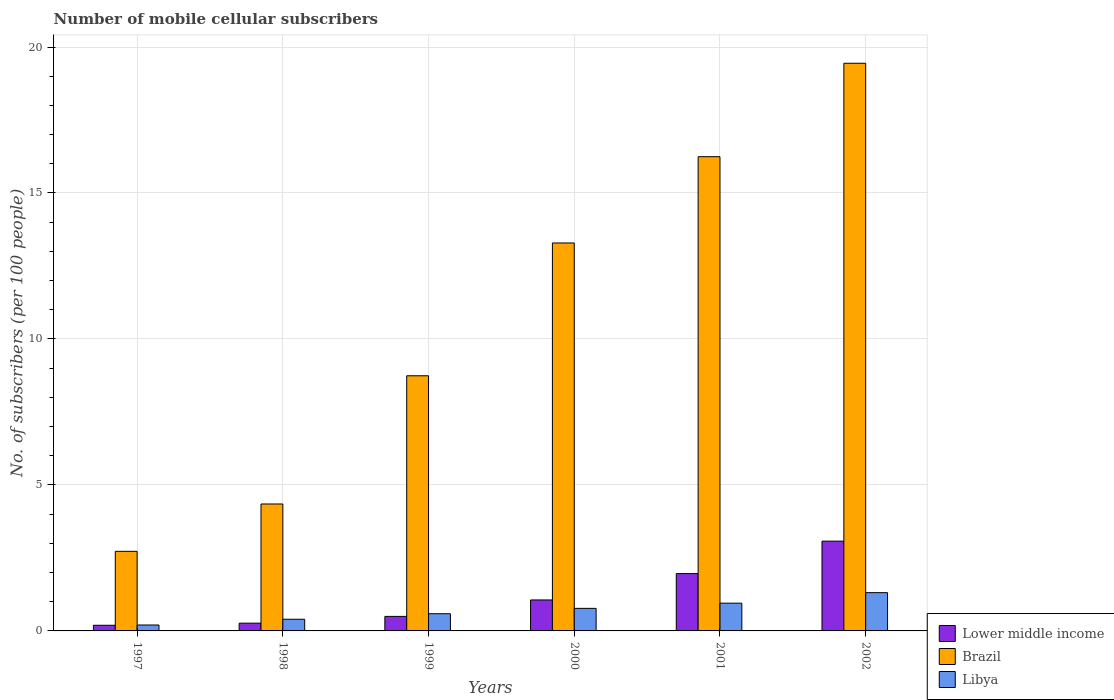How many different coloured bars are there?
Give a very brief answer. 3. How many groups of bars are there?
Offer a terse response. 6. Are the number of bars per tick equal to the number of legend labels?
Offer a terse response. Yes. How many bars are there on the 6th tick from the left?
Your response must be concise. 3. What is the label of the 1st group of bars from the left?
Your response must be concise. 1997. What is the number of mobile cellular subscribers in Brazil in 1999?
Offer a terse response. 8.74. Across all years, what is the maximum number of mobile cellular subscribers in Brazil?
Provide a succinct answer. 19.44. Across all years, what is the minimum number of mobile cellular subscribers in Libya?
Your response must be concise. 0.2. In which year was the number of mobile cellular subscribers in Libya maximum?
Your response must be concise. 2002. In which year was the number of mobile cellular subscribers in Brazil minimum?
Your answer should be very brief. 1997. What is the total number of mobile cellular subscribers in Libya in the graph?
Provide a succinct answer. 4.23. What is the difference between the number of mobile cellular subscribers in Libya in 2000 and that in 2001?
Keep it short and to the point. -0.18. What is the difference between the number of mobile cellular subscribers in Brazil in 2002 and the number of mobile cellular subscribers in Libya in 1999?
Provide a succinct answer. 18.85. What is the average number of mobile cellular subscribers in Libya per year?
Ensure brevity in your answer.  0.7. In the year 1998, what is the difference between the number of mobile cellular subscribers in Libya and number of mobile cellular subscribers in Lower middle income?
Give a very brief answer. 0.13. What is the ratio of the number of mobile cellular subscribers in Brazil in 1998 to that in 2000?
Offer a terse response. 0.33. Is the difference between the number of mobile cellular subscribers in Libya in 2000 and 2002 greater than the difference between the number of mobile cellular subscribers in Lower middle income in 2000 and 2002?
Provide a short and direct response. Yes. What is the difference between the highest and the second highest number of mobile cellular subscribers in Brazil?
Offer a very short reply. 3.2. What is the difference between the highest and the lowest number of mobile cellular subscribers in Brazil?
Your response must be concise. 16.72. In how many years, is the number of mobile cellular subscribers in Libya greater than the average number of mobile cellular subscribers in Libya taken over all years?
Provide a short and direct response. 3. Is the sum of the number of mobile cellular subscribers in Brazil in 1999 and 2001 greater than the maximum number of mobile cellular subscribers in Lower middle income across all years?
Make the answer very short. Yes. What does the 1st bar from the left in 1999 represents?
Your answer should be compact. Lower middle income. What does the 1st bar from the right in 1999 represents?
Provide a short and direct response. Libya. How many bars are there?
Provide a short and direct response. 18. Are all the bars in the graph horizontal?
Keep it short and to the point. No. How many years are there in the graph?
Keep it short and to the point. 6. Are the values on the major ticks of Y-axis written in scientific E-notation?
Ensure brevity in your answer.  No. Does the graph contain grids?
Offer a terse response. Yes. How many legend labels are there?
Keep it short and to the point. 3. How are the legend labels stacked?
Give a very brief answer. Vertical. What is the title of the graph?
Offer a terse response. Number of mobile cellular subscribers. What is the label or title of the X-axis?
Your answer should be compact. Years. What is the label or title of the Y-axis?
Offer a very short reply. No. of subscribers (per 100 people). What is the No. of subscribers (per 100 people) in Lower middle income in 1997?
Your response must be concise. 0.19. What is the No. of subscribers (per 100 people) in Brazil in 1997?
Ensure brevity in your answer.  2.73. What is the No. of subscribers (per 100 people) in Libya in 1997?
Provide a short and direct response. 0.2. What is the No. of subscribers (per 100 people) in Lower middle income in 1998?
Make the answer very short. 0.27. What is the No. of subscribers (per 100 people) of Brazil in 1998?
Provide a short and direct response. 4.35. What is the No. of subscribers (per 100 people) in Libya in 1998?
Make the answer very short. 0.4. What is the No. of subscribers (per 100 people) in Lower middle income in 1999?
Provide a short and direct response. 0.5. What is the No. of subscribers (per 100 people) in Brazil in 1999?
Provide a short and direct response. 8.74. What is the No. of subscribers (per 100 people) in Libya in 1999?
Your answer should be compact. 0.59. What is the No. of subscribers (per 100 people) in Lower middle income in 2000?
Offer a terse response. 1.06. What is the No. of subscribers (per 100 people) in Brazil in 2000?
Give a very brief answer. 13.29. What is the No. of subscribers (per 100 people) of Libya in 2000?
Provide a short and direct response. 0.77. What is the No. of subscribers (per 100 people) in Lower middle income in 2001?
Your response must be concise. 1.96. What is the No. of subscribers (per 100 people) in Brazil in 2001?
Give a very brief answer. 16.24. What is the No. of subscribers (per 100 people) of Libya in 2001?
Your response must be concise. 0.95. What is the No. of subscribers (per 100 people) of Lower middle income in 2002?
Your answer should be very brief. 3.07. What is the No. of subscribers (per 100 people) of Brazil in 2002?
Offer a terse response. 19.44. What is the No. of subscribers (per 100 people) in Libya in 2002?
Your answer should be very brief. 1.31. Across all years, what is the maximum No. of subscribers (per 100 people) in Lower middle income?
Offer a very short reply. 3.07. Across all years, what is the maximum No. of subscribers (per 100 people) in Brazil?
Your response must be concise. 19.44. Across all years, what is the maximum No. of subscribers (per 100 people) in Libya?
Offer a terse response. 1.31. Across all years, what is the minimum No. of subscribers (per 100 people) in Lower middle income?
Your answer should be compact. 0.19. Across all years, what is the minimum No. of subscribers (per 100 people) of Brazil?
Give a very brief answer. 2.73. Across all years, what is the minimum No. of subscribers (per 100 people) in Libya?
Provide a short and direct response. 0.2. What is the total No. of subscribers (per 100 people) in Lower middle income in the graph?
Offer a terse response. 7.06. What is the total No. of subscribers (per 100 people) of Brazil in the graph?
Give a very brief answer. 64.79. What is the total No. of subscribers (per 100 people) in Libya in the graph?
Give a very brief answer. 4.23. What is the difference between the No. of subscribers (per 100 people) in Lower middle income in 1997 and that in 1998?
Your answer should be compact. -0.07. What is the difference between the No. of subscribers (per 100 people) of Brazil in 1997 and that in 1998?
Your answer should be compact. -1.62. What is the difference between the No. of subscribers (per 100 people) of Libya in 1997 and that in 1998?
Ensure brevity in your answer.  -0.2. What is the difference between the No. of subscribers (per 100 people) in Lower middle income in 1997 and that in 1999?
Your answer should be compact. -0.3. What is the difference between the No. of subscribers (per 100 people) in Brazil in 1997 and that in 1999?
Ensure brevity in your answer.  -6.01. What is the difference between the No. of subscribers (per 100 people) of Libya in 1997 and that in 1999?
Give a very brief answer. -0.39. What is the difference between the No. of subscribers (per 100 people) of Lower middle income in 1997 and that in 2000?
Give a very brief answer. -0.87. What is the difference between the No. of subscribers (per 100 people) of Brazil in 1997 and that in 2000?
Give a very brief answer. -10.56. What is the difference between the No. of subscribers (per 100 people) in Libya in 1997 and that in 2000?
Your answer should be very brief. -0.57. What is the difference between the No. of subscribers (per 100 people) in Lower middle income in 1997 and that in 2001?
Your answer should be very brief. -1.77. What is the difference between the No. of subscribers (per 100 people) in Brazil in 1997 and that in 2001?
Offer a very short reply. -13.52. What is the difference between the No. of subscribers (per 100 people) in Libya in 1997 and that in 2001?
Provide a succinct answer. -0.75. What is the difference between the No. of subscribers (per 100 people) of Lower middle income in 1997 and that in 2002?
Keep it short and to the point. -2.88. What is the difference between the No. of subscribers (per 100 people) of Brazil in 1997 and that in 2002?
Offer a very short reply. -16.72. What is the difference between the No. of subscribers (per 100 people) in Libya in 1997 and that in 2002?
Provide a succinct answer. -1.11. What is the difference between the No. of subscribers (per 100 people) in Lower middle income in 1998 and that in 1999?
Your answer should be compact. -0.23. What is the difference between the No. of subscribers (per 100 people) of Brazil in 1998 and that in 1999?
Make the answer very short. -4.39. What is the difference between the No. of subscribers (per 100 people) of Libya in 1998 and that in 1999?
Your answer should be compact. -0.19. What is the difference between the No. of subscribers (per 100 people) of Lower middle income in 1998 and that in 2000?
Your response must be concise. -0.79. What is the difference between the No. of subscribers (per 100 people) of Brazil in 1998 and that in 2000?
Ensure brevity in your answer.  -8.94. What is the difference between the No. of subscribers (per 100 people) of Libya in 1998 and that in 2000?
Offer a very short reply. -0.37. What is the difference between the No. of subscribers (per 100 people) of Lower middle income in 1998 and that in 2001?
Your answer should be very brief. -1.7. What is the difference between the No. of subscribers (per 100 people) of Brazil in 1998 and that in 2001?
Ensure brevity in your answer.  -11.9. What is the difference between the No. of subscribers (per 100 people) of Libya in 1998 and that in 2001?
Your response must be concise. -0.55. What is the difference between the No. of subscribers (per 100 people) in Lower middle income in 1998 and that in 2002?
Ensure brevity in your answer.  -2.81. What is the difference between the No. of subscribers (per 100 people) in Brazil in 1998 and that in 2002?
Ensure brevity in your answer.  -15.1. What is the difference between the No. of subscribers (per 100 people) of Libya in 1998 and that in 2002?
Provide a succinct answer. -0.91. What is the difference between the No. of subscribers (per 100 people) in Lower middle income in 1999 and that in 2000?
Your answer should be very brief. -0.56. What is the difference between the No. of subscribers (per 100 people) of Brazil in 1999 and that in 2000?
Provide a short and direct response. -4.55. What is the difference between the No. of subscribers (per 100 people) of Libya in 1999 and that in 2000?
Ensure brevity in your answer.  -0.18. What is the difference between the No. of subscribers (per 100 people) of Lower middle income in 1999 and that in 2001?
Give a very brief answer. -1.47. What is the difference between the No. of subscribers (per 100 people) in Brazil in 1999 and that in 2001?
Your answer should be compact. -7.5. What is the difference between the No. of subscribers (per 100 people) in Libya in 1999 and that in 2001?
Your response must be concise. -0.36. What is the difference between the No. of subscribers (per 100 people) of Lower middle income in 1999 and that in 2002?
Give a very brief answer. -2.58. What is the difference between the No. of subscribers (per 100 people) in Brazil in 1999 and that in 2002?
Your response must be concise. -10.7. What is the difference between the No. of subscribers (per 100 people) of Libya in 1999 and that in 2002?
Give a very brief answer. -0.72. What is the difference between the No. of subscribers (per 100 people) in Lower middle income in 2000 and that in 2001?
Provide a short and direct response. -0.9. What is the difference between the No. of subscribers (per 100 people) in Brazil in 2000 and that in 2001?
Make the answer very short. -2.96. What is the difference between the No. of subscribers (per 100 people) of Libya in 2000 and that in 2001?
Make the answer very short. -0.18. What is the difference between the No. of subscribers (per 100 people) in Lower middle income in 2000 and that in 2002?
Your answer should be compact. -2.01. What is the difference between the No. of subscribers (per 100 people) of Brazil in 2000 and that in 2002?
Provide a succinct answer. -6.16. What is the difference between the No. of subscribers (per 100 people) of Libya in 2000 and that in 2002?
Make the answer very short. -0.54. What is the difference between the No. of subscribers (per 100 people) in Lower middle income in 2001 and that in 2002?
Give a very brief answer. -1.11. What is the difference between the No. of subscribers (per 100 people) of Brazil in 2001 and that in 2002?
Ensure brevity in your answer.  -3.2. What is the difference between the No. of subscribers (per 100 people) in Libya in 2001 and that in 2002?
Provide a succinct answer. -0.36. What is the difference between the No. of subscribers (per 100 people) of Lower middle income in 1997 and the No. of subscribers (per 100 people) of Brazil in 1998?
Your answer should be compact. -4.15. What is the difference between the No. of subscribers (per 100 people) in Lower middle income in 1997 and the No. of subscribers (per 100 people) in Libya in 1998?
Keep it short and to the point. -0.21. What is the difference between the No. of subscribers (per 100 people) of Brazil in 1997 and the No. of subscribers (per 100 people) of Libya in 1998?
Your answer should be very brief. 2.33. What is the difference between the No. of subscribers (per 100 people) of Lower middle income in 1997 and the No. of subscribers (per 100 people) of Brazil in 1999?
Ensure brevity in your answer.  -8.55. What is the difference between the No. of subscribers (per 100 people) in Lower middle income in 1997 and the No. of subscribers (per 100 people) in Libya in 1999?
Give a very brief answer. -0.4. What is the difference between the No. of subscribers (per 100 people) of Brazil in 1997 and the No. of subscribers (per 100 people) of Libya in 1999?
Make the answer very short. 2.14. What is the difference between the No. of subscribers (per 100 people) of Lower middle income in 1997 and the No. of subscribers (per 100 people) of Brazil in 2000?
Ensure brevity in your answer.  -13.09. What is the difference between the No. of subscribers (per 100 people) in Lower middle income in 1997 and the No. of subscribers (per 100 people) in Libya in 2000?
Provide a succinct answer. -0.58. What is the difference between the No. of subscribers (per 100 people) of Brazil in 1997 and the No. of subscribers (per 100 people) of Libya in 2000?
Give a very brief answer. 1.95. What is the difference between the No. of subscribers (per 100 people) in Lower middle income in 1997 and the No. of subscribers (per 100 people) in Brazil in 2001?
Offer a terse response. -16.05. What is the difference between the No. of subscribers (per 100 people) in Lower middle income in 1997 and the No. of subscribers (per 100 people) in Libya in 2001?
Give a very brief answer. -0.76. What is the difference between the No. of subscribers (per 100 people) in Brazil in 1997 and the No. of subscribers (per 100 people) in Libya in 2001?
Your answer should be very brief. 1.77. What is the difference between the No. of subscribers (per 100 people) in Lower middle income in 1997 and the No. of subscribers (per 100 people) in Brazil in 2002?
Provide a short and direct response. -19.25. What is the difference between the No. of subscribers (per 100 people) of Lower middle income in 1997 and the No. of subscribers (per 100 people) of Libya in 2002?
Provide a short and direct response. -1.12. What is the difference between the No. of subscribers (per 100 people) of Brazil in 1997 and the No. of subscribers (per 100 people) of Libya in 2002?
Your answer should be very brief. 1.42. What is the difference between the No. of subscribers (per 100 people) of Lower middle income in 1998 and the No. of subscribers (per 100 people) of Brazil in 1999?
Make the answer very short. -8.47. What is the difference between the No. of subscribers (per 100 people) in Lower middle income in 1998 and the No. of subscribers (per 100 people) in Libya in 1999?
Your answer should be very brief. -0.32. What is the difference between the No. of subscribers (per 100 people) in Brazil in 1998 and the No. of subscribers (per 100 people) in Libya in 1999?
Keep it short and to the point. 3.76. What is the difference between the No. of subscribers (per 100 people) of Lower middle income in 1998 and the No. of subscribers (per 100 people) of Brazil in 2000?
Your response must be concise. -13.02. What is the difference between the No. of subscribers (per 100 people) in Lower middle income in 1998 and the No. of subscribers (per 100 people) in Libya in 2000?
Your answer should be very brief. -0.51. What is the difference between the No. of subscribers (per 100 people) of Brazil in 1998 and the No. of subscribers (per 100 people) of Libya in 2000?
Your answer should be compact. 3.58. What is the difference between the No. of subscribers (per 100 people) in Lower middle income in 1998 and the No. of subscribers (per 100 people) in Brazil in 2001?
Offer a very short reply. -15.98. What is the difference between the No. of subscribers (per 100 people) of Lower middle income in 1998 and the No. of subscribers (per 100 people) of Libya in 2001?
Provide a short and direct response. -0.69. What is the difference between the No. of subscribers (per 100 people) of Brazil in 1998 and the No. of subscribers (per 100 people) of Libya in 2001?
Keep it short and to the point. 3.4. What is the difference between the No. of subscribers (per 100 people) in Lower middle income in 1998 and the No. of subscribers (per 100 people) in Brazil in 2002?
Your response must be concise. -19.18. What is the difference between the No. of subscribers (per 100 people) in Lower middle income in 1998 and the No. of subscribers (per 100 people) in Libya in 2002?
Your answer should be compact. -1.04. What is the difference between the No. of subscribers (per 100 people) in Brazil in 1998 and the No. of subscribers (per 100 people) in Libya in 2002?
Your answer should be very brief. 3.04. What is the difference between the No. of subscribers (per 100 people) in Lower middle income in 1999 and the No. of subscribers (per 100 people) in Brazil in 2000?
Your answer should be compact. -12.79. What is the difference between the No. of subscribers (per 100 people) in Lower middle income in 1999 and the No. of subscribers (per 100 people) in Libya in 2000?
Give a very brief answer. -0.28. What is the difference between the No. of subscribers (per 100 people) in Brazil in 1999 and the No. of subscribers (per 100 people) in Libya in 2000?
Keep it short and to the point. 7.97. What is the difference between the No. of subscribers (per 100 people) in Lower middle income in 1999 and the No. of subscribers (per 100 people) in Brazil in 2001?
Offer a very short reply. -15.75. What is the difference between the No. of subscribers (per 100 people) in Lower middle income in 1999 and the No. of subscribers (per 100 people) in Libya in 2001?
Keep it short and to the point. -0.45. What is the difference between the No. of subscribers (per 100 people) of Brazil in 1999 and the No. of subscribers (per 100 people) of Libya in 2001?
Offer a very short reply. 7.79. What is the difference between the No. of subscribers (per 100 people) in Lower middle income in 1999 and the No. of subscribers (per 100 people) in Brazil in 2002?
Your answer should be very brief. -18.95. What is the difference between the No. of subscribers (per 100 people) in Lower middle income in 1999 and the No. of subscribers (per 100 people) in Libya in 2002?
Offer a very short reply. -0.81. What is the difference between the No. of subscribers (per 100 people) in Brazil in 1999 and the No. of subscribers (per 100 people) in Libya in 2002?
Give a very brief answer. 7.43. What is the difference between the No. of subscribers (per 100 people) in Lower middle income in 2000 and the No. of subscribers (per 100 people) in Brazil in 2001?
Provide a succinct answer. -15.18. What is the difference between the No. of subscribers (per 100 people) of Lower middle income in 2000 and the No. of subscribers (per 100 people) of Libya in 2001?
Offer a terse response. 0.11. What is the difference between the No. of subscribers (per 100 people) in Brazil in 2000 and the No. of subscribers (per 100 people) in Libya in 2001?
Your answer should be compact. 12.34. What is the difference between the No. of subscribers (per 100 people) of Lower middle income in 2000 and the No. of subscribers (per 100 people) of Brazil in 2002?
Offer a terse response. -18.38. What is the difference between the No. of subscribers (per 100 people) of Brazil in 2000 and the No. of subscribers (per 100 people) of Libya in 2002?
Your response must be concise. 11.98. What is the difference between the No. of subscribers (per 100 people) in Lower middle income in 2001 and the No. of subscribers (per 100 people) in Brazil in 2002?
Provide a short and direct response. -17.48. What is the difference between the No. of subscribers (per 100 people) of Lower middle income in 2001 and the No. of subscribers (per 100 people) of Libya in 2002?
Offer a terse response. 0.65. What is the difference between the No. of subscribers (per 100 people) in Brazil in 2001 and the No. of subscribers (per 100 people) in Libya in 2002?
Keep it short and to the point. 14.93. What is the average No. of subscribers (per 100 people) of Lower middle income per year?
Offer a very short reply. 1.18. What is the average No. of subscribers (per 100 people) in Brazil per year?
Ensure brevity in your answer.  10.8. What is the average No. of subscribers (per 100 people) in Libya per year?
Give a very brief answer. 0.7. In the year 1997, what is the difference between the No. of subscribers (per 100 people) in Lower middle income and No. of subscribers (per 100 people) in Brazil?
Ensure brevity in your answer.  -2.53. In the year 1997, what is the difference between the No. of subscribers (per 100 people) in Lower middle income and No. of subscribers (per 100 people) in Libya?
Ensure brevity in your answer.  -0.01. In the year 1997, what is the difference between the No. of subscribers (per 100 people) of Brazil and No. of subscribers (per 100 people) of Libya?
Your response must be concise. 2.52. In the year 1998, what is the difference between the No. of subscribers (per 100 people) in Lower middle income and No. of subscribers (per 100 people) in Brazil?
Offer a very short reply. -4.08. In the year 1998, what is the difference between the No. of subscribers (per 100 people) in Lower middle income and No. of subscribers (per 100 people) in Libya?
Make the answer very short. -0.13. In the year 1998, what is the difference between the No. of subscribers (per 100 people) in Brazil and No. of subscribers (per 100 people) in Libya?
Give a very brief answer. 3.95. In the year 1999, what is the difference between the No. of subscribers (per 100 people) in Lower middle income and No. of subscribers (per 100 people) in Brazil?
Your answer should be compact. -8.24. In the year 1999, what is the difference between the No. of subscribers (per 100 people) of Lower middle income and No. of subscribers (per 100 people) of Libya?
Your answer should be very brief. -0.09. In the year 1999, what is the difference between the No. of subscribers (per 100 people) of Brazil and No. of subscribers (per 100 people) of Libya?
Give a very brief answer. 8.15. In the year 2000, what is the difference between the No. of subscribers (per 100 people) in Lower middle income and No. of subscribers (per 100 people) in Brazil?
Your response must be concise. -12.23. In the year 2000, what is the difference between the No. of subscribers (per 100 people) in Lower middle income and No. of subscribers (per 100 people) in Libya?
Make the answer very short. 0.29. In the year 2000, what is the difference between the No. of subscribers (per 100 people) in Brazil and No. of subscribers (per 100 people) in Libya?
Offer a terse response. 12.52. In the year 2001, what is the difference between the No. of subscribers (per 100 people) in Lower middle income and No. of subscribers (per 100 people) in Brazil?
Keep it short and to the point. -14.28. In the year 2001, what is the difference between the No. of subscribers (per 100 people) of Lower middle income and No. of subscribers (per 100 people) of Libya?
Make the answer very short. 1.01. In the year 2001, what is the difference between the No. of subscribers (per 100 people) in Brazil and No. of subscribers (per 100 people) in Libya?
Give a very brief answer. 15.29. In the year 2002, what is the difference between the No. of subscribers (per 100 people) of Lower middle income and No. of subscribers (per 100 people) of Brazil?
Keep it short and to the point. -16.37. In the year 2002, what is the difference between the No. of subscribers (per 100 people) of Lower middle income and No. of subscribers (per 100 people) of Libya?
Offer a very short reply. 1.76. In the year 2002, what is the difference between the No. of subscribers (per 100 people) of Brazil and No. of subscribers (per 100 people) of Libya?
Ensure brevity in your answer.  18.13. What is the ratio of the No. of subscribers (per 100 people) of Lower middle income in 1997 to that in 1998?
Offer a terse response. 0.73. What is the ratio of the No. of subscribers (per 100 people) in Brazil in 1997 to that in 1998?
Ensure brevity in your answer.  0.63. What is the ratio of the No. of subscribers (per 100 people) in Libya in 1997 to that in 1998?
Provide a short and direct response. 0.51. What is the ratio of the No. of subscribers (per 100 people) of Lower middle income in 1997 to that in 1999?
Give a very brief answer. 0.39. What is the ratio of the No. of subscribers (per 100 people) in Brazil in 1997 to that in 1999?
Keep it short and to the point. 0.31. What is the ratio of the No. of subscribers (per 100 people) of Libya in 1997 to that in 1999?
Your answer should be very brief. 0.34. What is the ratio of the No. of subscribers (per 100 people) in Lower middle income in 1997 to that in 2000?
Your answer should be very brief. 0.18. What is the ratio of the No. of subscribers (per 100 people) of Brazil in 1997 to that in 2000?
Provide a short and direct response. 0.21. What is the ratio of the No. of subscribers (per 100 people) in Libya in 1997 to that in 2000?
Give a very brief answer. 0.26. What is the ratio of the No. of subscribers (per 100 people) in Lower middle income in 1997 to that in 2001?
Keep it short and to the point. 0.1. What is the ratio of the No. of subscribers (per 100 people) in Brazil in 1997 to that in 2001?
Keep it short and to the point. 0.17. What is the ratio of the No. of subscribers (per 100 people) in Libya in 1997 to that in 2001?
Your answer should be very brief. 0.21. What is the ratio of the No. of subscribers (per 100 people) in Lower middle income in 1997 to that in 2002?
Keep it short and to the point. 0.06. What is the ratio of the No. of subscribers (per 100 people) in Brazil in 1997 to that in 2002?
Your answer should be very brief. 0.14. What is the ratio of the No. of subscribers (per 100 people) in Libya in 1997 to that in 2002?
Your answer should be very brief. 0.15. What is the ratio of the No. of subscribers (per 100 people) in Lower middle income in 1998 to that in 1999?
Offer a terse response. 0.53. What is the ratio of the No. of subscribers (per 100 people) in Brazil in 1998 to that in 1999?
Your answer should be compact. 0.5. What is the ratio of the No. of subscribers (per 100 people) in Libya in 1998 to that in 1999?
Keep it short and to the point. 0.68. What is the ratio of the No. of subscribers (per 100 people) of Lower middle income in 1998 to that in 2000?
Keep it short and to the point. 0.25. What is the ratio of the No. of subscribers (per 100 people) of Brazil in 1998 to that in 2000?
Offer a terse response. 0.33. What is the ratio of the No. of subscribers (per 100 people) of Libya in 1998 to that in 2000?
Your response must be concise. 0.52. What is the ratio of the No. of subscribers (per 100 people) of Lower middle income in 1998 to that in 2001?
Give a very brief answer. 0.14. What is the ratio of the No. of subscribers (per 100 people) of Brazil in 1998 to that in 2001?
Keep it short and to the point. 0.27. What is the ratio of the No. of subscribers (per 100 people) in Libya in 1998 to that in 2001?
Ensure brevity in your answer.  0.42. What is the ratio of the No. of subscribers (per 100 people) in Lower middle income in 1998 to that in 2002?
Offer a terse response. 0.09. What is the ratio of the No. of subscribers (per 100 people) of Brazil in 1998 to that in 2002?
Provide a short and direct response. 0.22. What is the ratio of the No. of subscribers (per 100 people) of Libya in 1998 to that in 2002?
Provide a succinct answer. 0.3. What is the ratio of the No. of subscribers (per 100 people) of Lower middle income in 1999 to that in 2000?
Your answer should be very brief. 0.47. What is the ratio of the No. of subscribers (per 100 people) in Brazil in 1999 to that in 2000?
Your answer should be very brief. 0.66. What is the ratio of the No. of subscribers (per 100 people) in Libya in 1999 to that in 2000?
Your response must be concise. 0.76. What is the ratio of the No. of subscribers (per 100 people) of Lower middle income in 1999 to that in 2001?
Provide a succinct answer. 0.25. What is the ratio of the No. of subscribers (per 100 people) in Brazil in 1999 to that in 2001?
Ensure brevity in your answer.  0.54. What is the ratio of the No. of subscribers (per 100 people) in Libya in 1999 to that in 2001?
Give a very brief answer. 0.62. What is the ratio of the No. of subscribers (per 100 people) in Lower middle income in 1999 to that in 2002?
Your answer should be very brief. 0.16. What is the ratio of the No. of subscribers (per 100 people) in Brazil in 1999 to that in 2002?
Ensure brevity in your answer.  0.45. What is the ratio of the No. of subscribers (per 100 people) of Libya in 1999 to that in 2002?
Provide a short and direct response. 0.45. What is the ratio of the No. of subscribers (per 100 people) of Lower middle income in 2000 to that in 2001?
Make the answer very short. 0.54. What is the ratio of the No. of subscribers (per 100 people) of Brazil in 2000 to that in 2001?
Your answer should be compact. 0.82. What is the ratio of the No. of subscribers (per 100 people) of Libya in 2000 to that in 2001?
Keep it short and to the point. 0.81. What is the ratio of the No. of subscribers (per 100 people) of Lower middle income in 2000 to that in 2002?
Make the answer very short. 0.34. What is the ratio of the No. of subscribers (per 100 people) of Brazil in 2000 to that in 2002?
Your answer should be compact. 0.68. What is the ratio of the No. of subscribers (per 100 people) in Libya in 2000 to that in 2002?
Give a very brief answer. 0.59. What is the ratio of the No. of subscribers (per 100 people) in Lower middle income in 2001 to that in 2002?
Give a very brief answer. 0.64. What is the ratio of the No. of subscribers (per 100 people) in Brazil in 2001 to that in 2002?
Provide a succinct answer. 0.84. What is the ratio of the No. of subscribers (per 100 people) of Libya in 2001 to that in 2002?
Your response must be concise. 0.73. What is the difference between the highest and the second highest No. of subscribers (per 100 people) in Lower middle income?
Give a very brief answer. 1.11. What is the difference between the highest and the second highest No. of subscribers (per 100 people) in Brazil?
Make the answer very short. 3.2. What is the difference between the highest and the second highest No. of subscribers (per 100 people) in Libya?
Your answer should be compact. 0.36. What is the difference between the highest and the lowest No. of subscribers (per 100 people) of Lower middle income?
Make the answer very short. 2.88. What is the difference between the highest and the lowest No. of subscribers (per 100 people) in Brazil?
Your answer should be very brief. 16.72. What is the difference between the highest and the lowest No. of subscribers (per 100 people) in Libya?
Make the answer very short. 1.11. 